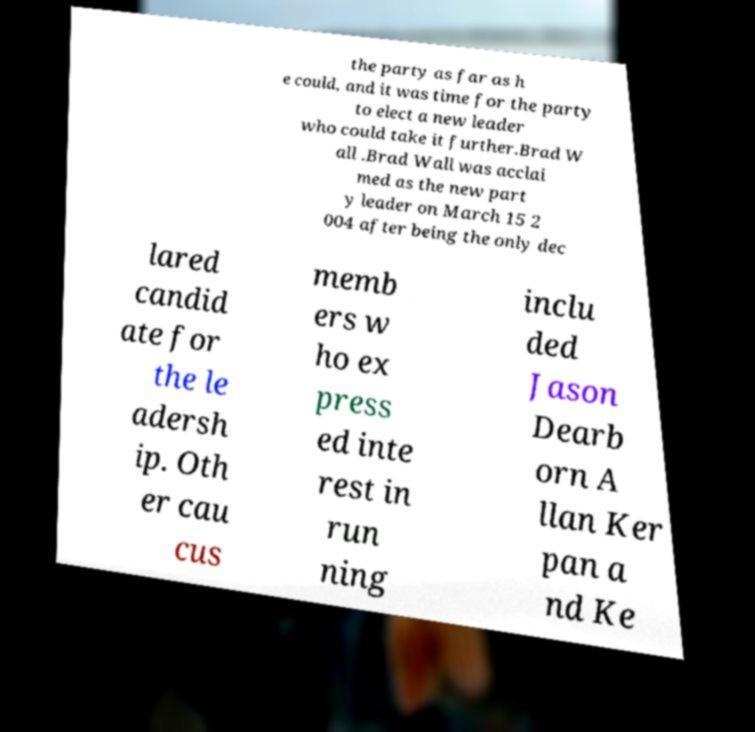For documentation purposes, I need the text within this image transcribed. Could you provide that? the party as far as h e could, and it was time for the party to elect a new leader who could take it further.Brad W all .Brad Wall was acclai med as the new part y leader on March 15 2 004 after being the only dec lared candid ate for the le adersh ip. Oth er cau cus memb ers w ho ex press ed inte rest in run ning inclu ded Jason Dearb orn A llan Ker pan a nd Ke 